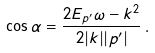<formula> <loc_0><loc_0><loc_500><loc_500>\cos \alpha = \frac { 2 E _ { p ^ { \prime } } \omega - k ^ { 2 } } { 2 { | k | | p ^ { \prime } | } } \, .</formula> 